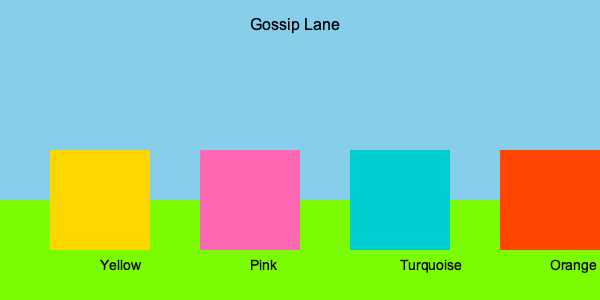You've heard through the grapevine that Mrs. Johnson, who always wears flamboyant pink outfits, just moved to Gossip Lane. Which house is likely to be hers? To determine which house likely belongs to Mrs. Johnson, we need to consider the following steps:

1. Recall the key information: Mrs. Johnson is known for wearing flamboyant pink outfits.
2. Observe the houses on Gossip Lane in the image.
3. There are four houses with different colors: Yellow, Pink, Turquoise, and Orange.
4. Given Mrs. Johnson's preference for pink, we can assume she would choose a house that matches her style.
5. The second house from the left is colored pink.
6. This pink house aligns with Mrs. Johnson's known fashion choices.

Therefore, based on the information provided and the visual representation of Gossip Lane, the pink house is most likely to belong to Mrs. Johnson.
Answer: The pink house 